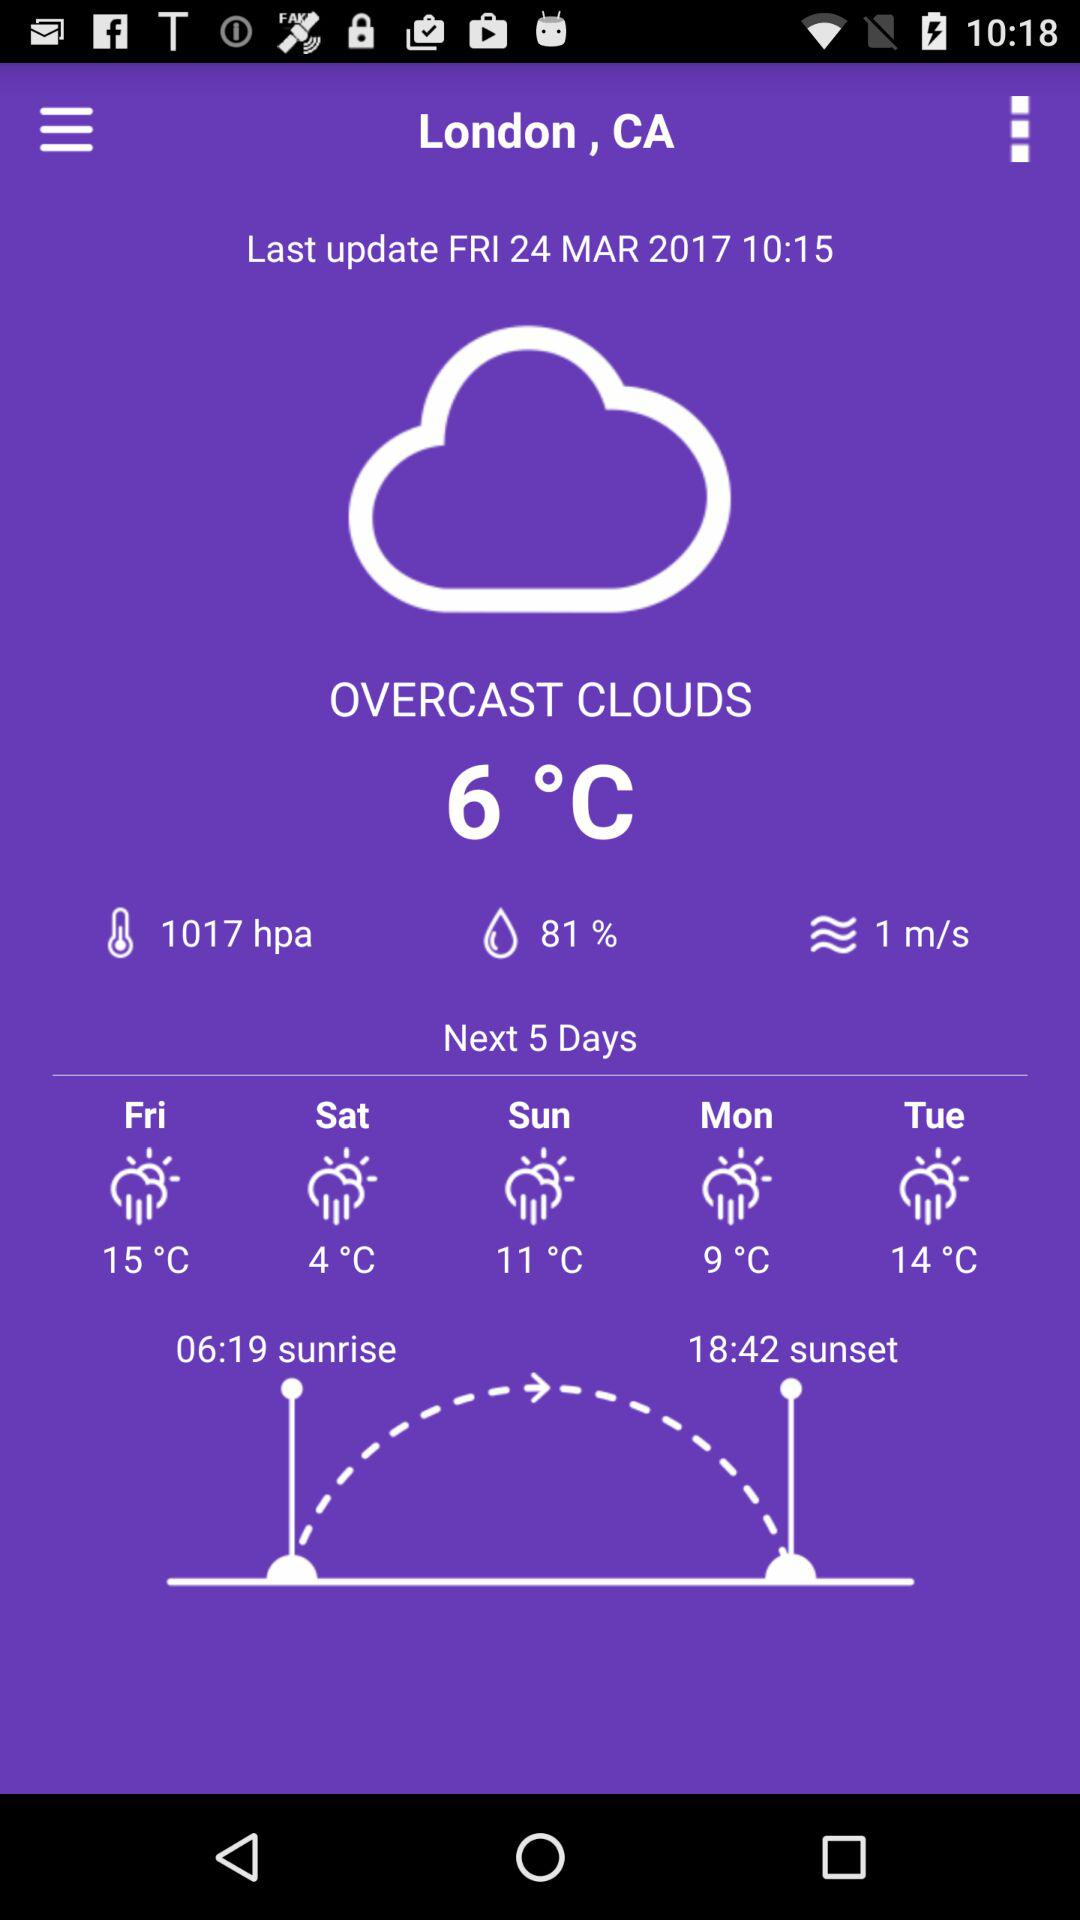What is the temperature on Saturday? The temperature on Saturday is 4 °C. 